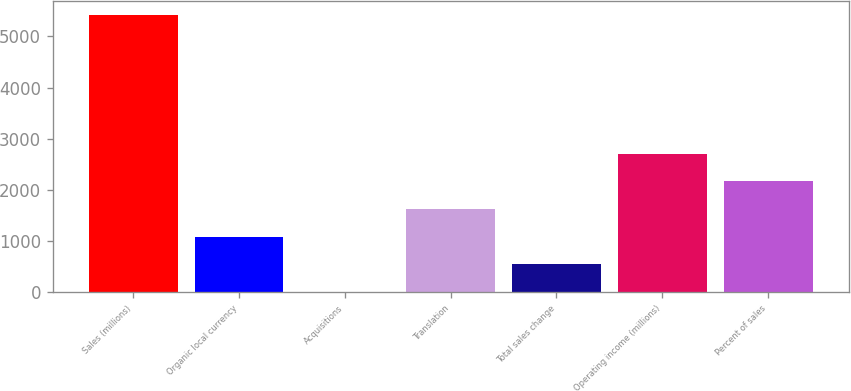Convert chart to OTSL. <chart><loc_0><loc_0><loc_500><loc_500><bar_chart><fcel>Sales (millions)<fcel>Organic local currency<fcel>Acquisitions<fcel>Translation<fcel>Total sales change<fcel>Operating income (millions)<fcel>Percent of sales<nl><fcel>5420<fcel>1084.64<fcel>0.8<fcel>1626.56<fcel>542.72<fcel>2710.4<fcel>2168.48<nl></chart> 